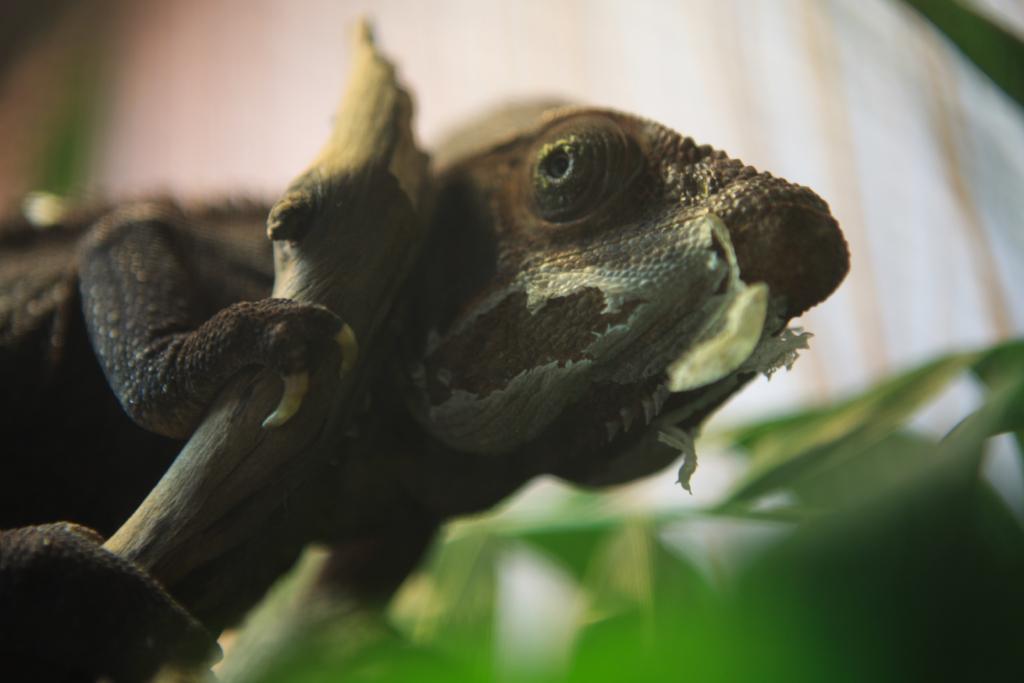How would you summarize this image in a sentence or two? In this image, this looks like a chameleon. This is the branch. The background looks blurry. 